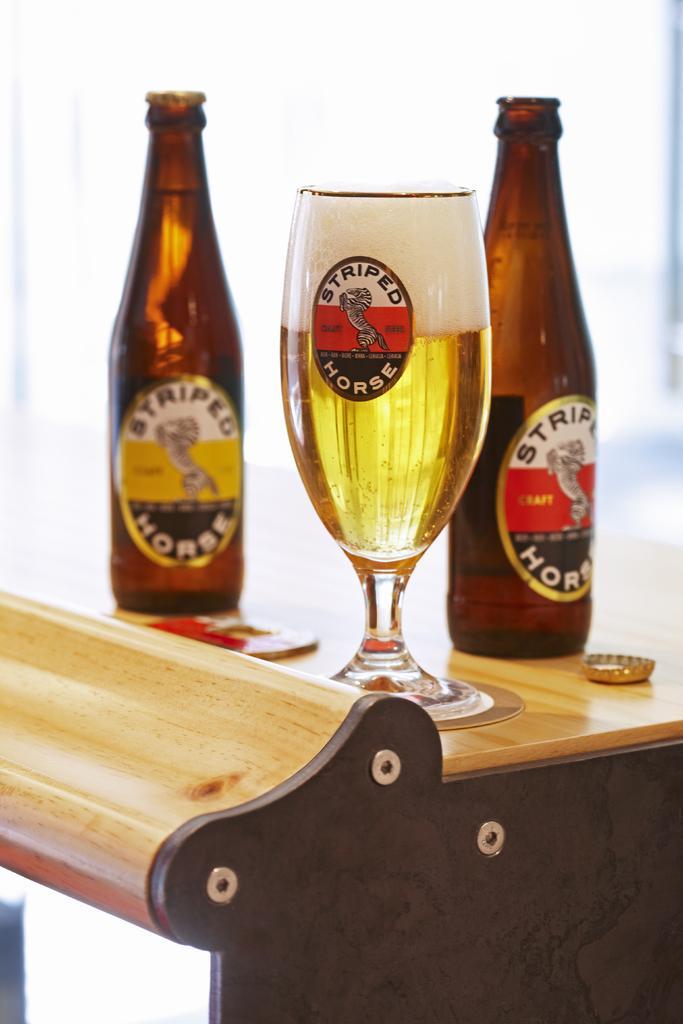Describe this image in one or two sentences. In the picture we can see a table, on the table we can see a glass of wine and two wine bottles, with a bottle cap on the table. On the bottle there is a sticker named STRIPED HORSES. 